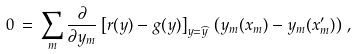<formula> <loc_0><loc_0><loc_500><loc_500>0 \, = \, \sum _ { m } \frac { \partial } { \partial y _ { m } } \left [ r ( y ) - g ( y ) \right ] _ { y = \widehat { y } } \, \left ( y _ { m } ( x _ { m } ) - y _ { m } ( x _ { m } ^ { \prime } ) \right ) \, ,</formula> 